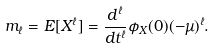Convert formula to latex. <formula><loc_0><loc_0><loc_500><loc_500>m _ { \ell } = E [ X ^ { \ell } ] = \frac { d ^ { \ell } } { d t ^ { \ell } } \phi _ { X } ( 0 ) ( - \mu ) ^ { \ell } .</formula> 